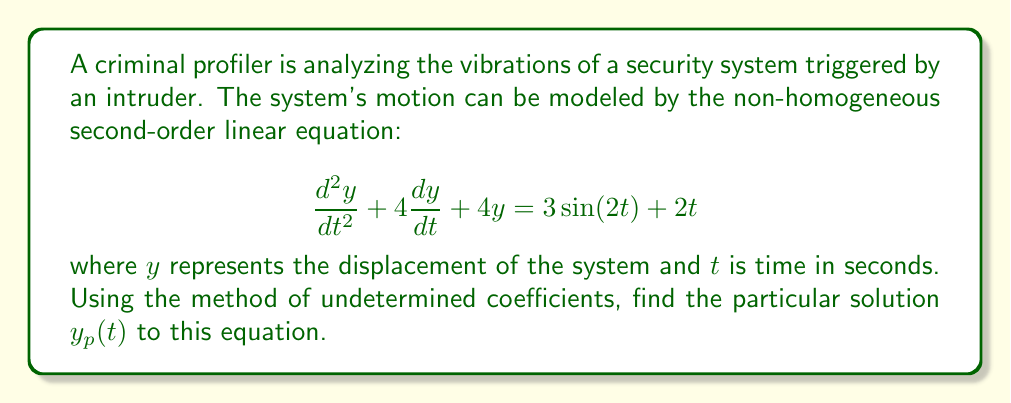Show me your answer to this math problem. To solve this problem using the method of undetermined coefficients, we follow these steps:

1) First, we identify the form of the particular solution based on the right-hand side of the equation. We have two terms:
   - $3\sin(2t)$: This suggests a solution of the form $A\cos(2t) + B\sin(2t)$
   - $2t$: This suggests a solution of the form $Ct + D$

   So, our particular solution will have the form:
   $$y_p(t) = A\cos(2t) + B\sin(2t) + Ct + D$$

2) We need to find the first and second derivatives of $y_p(t)$:
   $$\frac{dy_p}{dt} = -2A\sin(2t) + 2B\cos(2t) + C$$
   $$\frac{d^2y_p}{dt^2} = -4A\cos(2t) - 4B\sin(2t)$$

3) Substitute these into the original equation:
   $$(-4A\cos(2t) - 4B\sin(2t)) + 4(-2A\sin(2t) + 2B\cos(2t) + C) + 4(A\cos(2t) + B\sin(2t) + Ct + D) = 3\sin(2t) + 2t$$

4) Collect like terms:
   $$(4B-8A)\cos(2t) + (-4B-8A)\sin(2t) + 4Ct + 4C + 4D = 3\sin(2t) + 2t$$

5) Equate coefficients:
   $\cos(2t)$: $4B-8A = 0$
   $\sin(2t)$: $-4B-8A = 3$
   $t$: $4C = 2$
   constant: $4C + 4D = 0$

6) Solve this system of equations:
   From $4C = 2$, we get $C = \frac{1}{2}$
   From $4C + 4D = 0$, we get $D = -\frac{1}{2}$
   From $4B-8A = 0$, we get $B = 2A$
   Substituting this into $-4B-8A = 3$, we get:
   $-4(2A)-8A = 3$
   $-16A = 3$
   $A = -\frac{3}{16}$
   Therefore, $B = 2A = -\frac{3}{8}$

7) Substitute these values back into our particular solution:

   $$y_p(t) = -\frac{3}{16}\cos(2t) - \frac{3}{8}\sin(2t) + \frac{1}{2}t - \frac{1}{2}$$

This is our particular solution.
Answer: $$y_p(t) = -\frac{3}{16}\cos(2t) - \frac{3}{8}\sin(2t) + \frac{1}{2}t - \frac{1}{2}$$ 